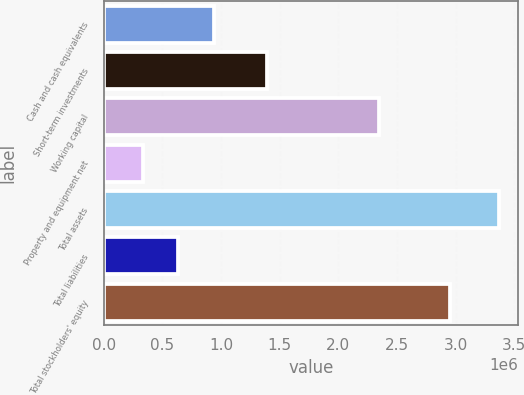Convert chart. <chart><loc_0><loc_0><loc_500><loc_500><bar_chart><fcel>Cash and cash equivalents<fcel>Short-term investments<fcel>Working capital<fcel>Property and equipment net<fcel>Total assets<fcel>Total liabilities<fcel>Total stockholders' equity<nl><fcel>939378<fcel>1.39304e+06<fcel>2.34925e+06<fcel>332662<fcel>3.36624e+06<fcel>636020<fcel>2.95001e+06<nl></chart> 